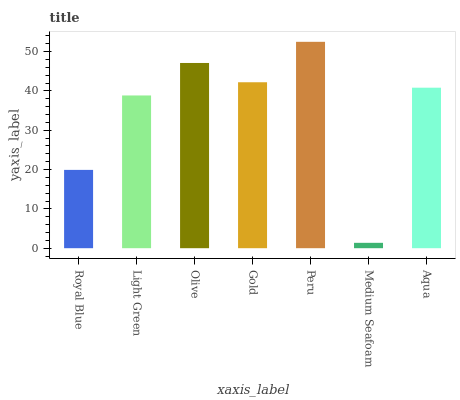Is Medium Seafoam the minimum?
Answer yes or no. Yes. Is Peru the maximum?
Answer yes or no. Yes. Is Light Green the minimum?
Answer yes or no. No. Is Light Green the maximum?
Answer yes or no. No. Is Light Green greater than Royal Blue?
Answer yes or no. Yes. Is Royal Blue less than Light Green?
Answer yes or no. Yes. Is Royal Blue greater than Light Green?
Answer yes or no. No. Is Light Green less than Royal Blue?
Answer yes or no. No. Is Aqua the high median?
Answer yes or no. Yes. Is Aqua the low median?
Answer yes or no. Yes. Is Medium Seafoam the high median?
Answer yes or no. No. Is Olive the low median?
Answer yes or no. No. 